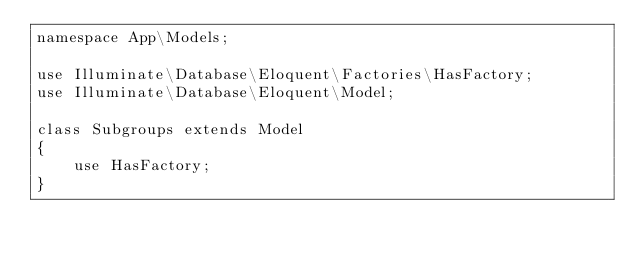Convert code to text. <code><loc_0><loc_0><loc_500><loc_500><_PHP_>namespace App\Models;

use Illuminate\Database\Eloquent\Factories\HasFactory;
use Illuminate\Database\Eloquent\Model;

class Subgroups extends Model
{
    use HasFactory;
}
</code> 